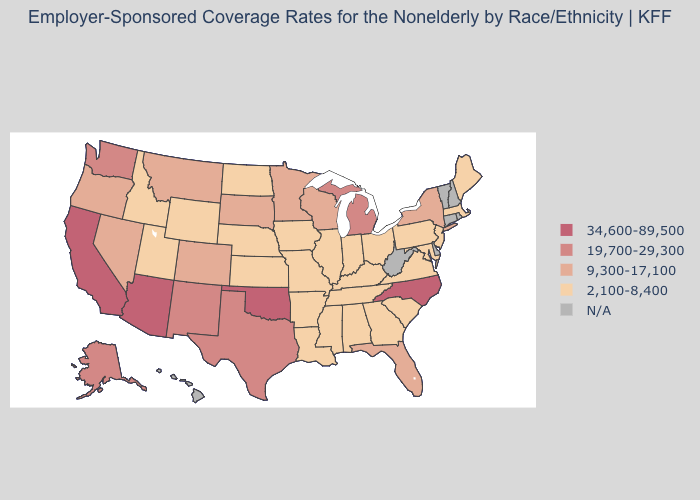Does the map have missing data?
Be succinct. Yes. What is the highest value in the West ?
Keep it brief. 34,600-89,500. What is the value of Massachusetts?
Quick response, please. 2,100-8,400. Name the states that have a value in the range 19,700-29,300?
Short answer required. Alaska, Michigan, New Mexico, Texas, Washington. What is the value of Kentucky?
Concise answer only. 2,100-8,400. What is the value of Nebraska?
Answer briefly. 2,100-8,400. Which states have the highest value in the USA?
Concise answer only. Arizona, California, North Carolina, Oklahoma. What is the value of Oregon?
Short answer required. 9,300-17,100. What is the lowest value in the USA?
Answer briefly. 2,100-8,400. What is the highest value in states that border North Carolina?
Keep it brief. 2,100-8,400. Name the states that have a value in the range 19,700-29,300?
Be succinct. Alaska, Michigan, New Mexico, Texas, Washington. Name the states that have a value in the range 34,600-89,500?
Write a very short answer. Arizona, California, North Carolina, Oklahoma. Among the states that border Florida , which have the highest value?
Be succinct. Alabama, Georgia. 